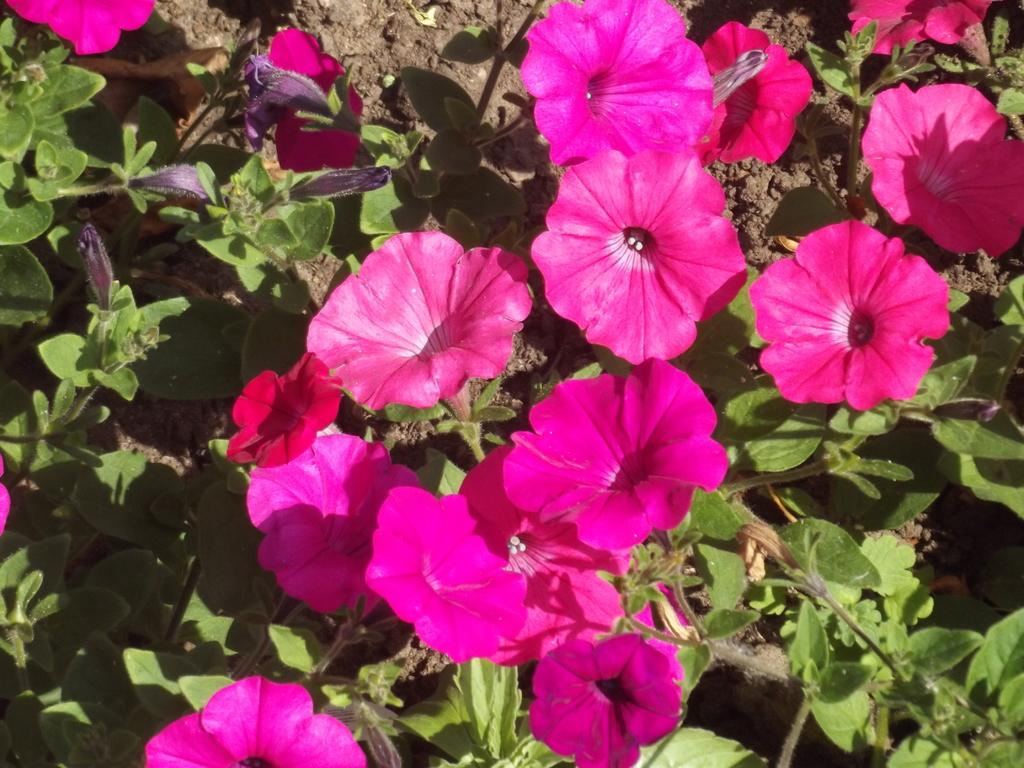What type of vegetation can be seen in the image? There are flowers and plants in the image. What is the ground made of in the image? There is mud visible in the image. What type of clouds can be seen in the image? There are no clouds visible in the image; it only features flowers, plants, and mud. 